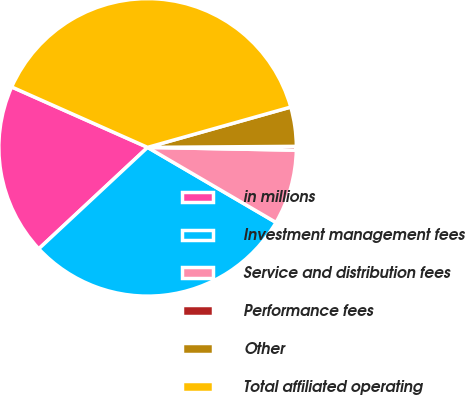Convert chart. <chart><loc_0><loc_0><loc_500><loc_500><pie_chart><fcel>in millions<fcel>Investment management fees<fcel>Service and distribution fees<fcel>Performance fees<fcel>Other<fcel>Total affiliated operating<nl><fcel>18.6%<fcel>29.64%<fcel>8.12%<fcel>0.41%<fcel>4.26%<fcel>38.97%<nl></chart> 